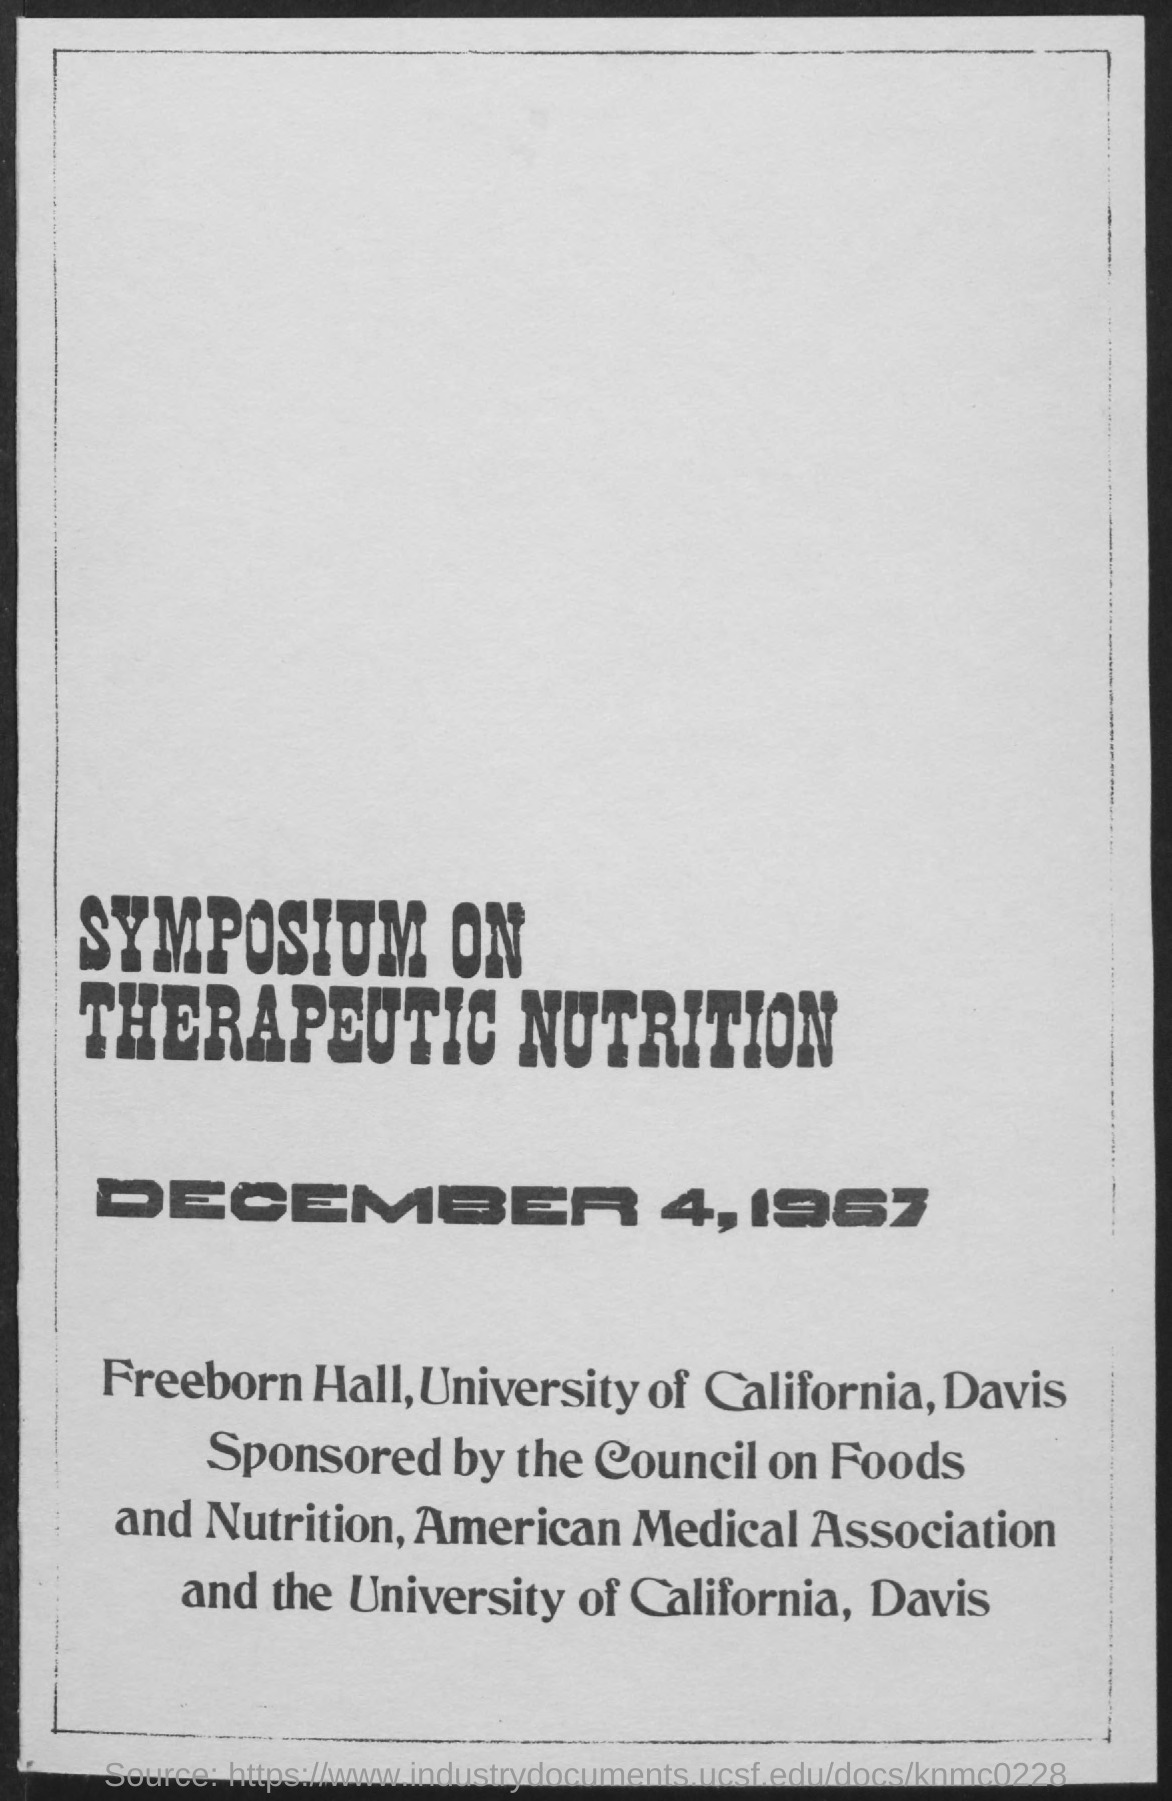What is the title of the document?
Your answer should be compact. Symposium on Therapeutic Nutrition. 